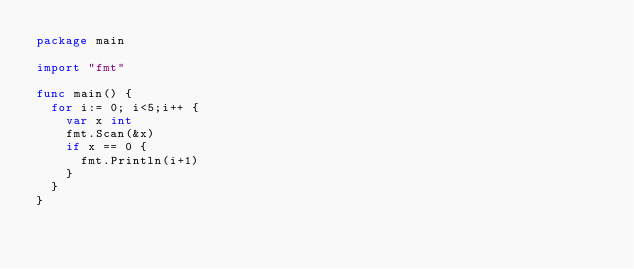<code> <loc_0><loc_0><loc_500><loc_500><_Go_>package main

import "fmt"

func main() {
	for i:= 0; i<5;i++ {
		var x int
		fmt.Scan(&x)
		if x == 0 {
			fmt.Println(i+1)
		}
	}
}
</code> 